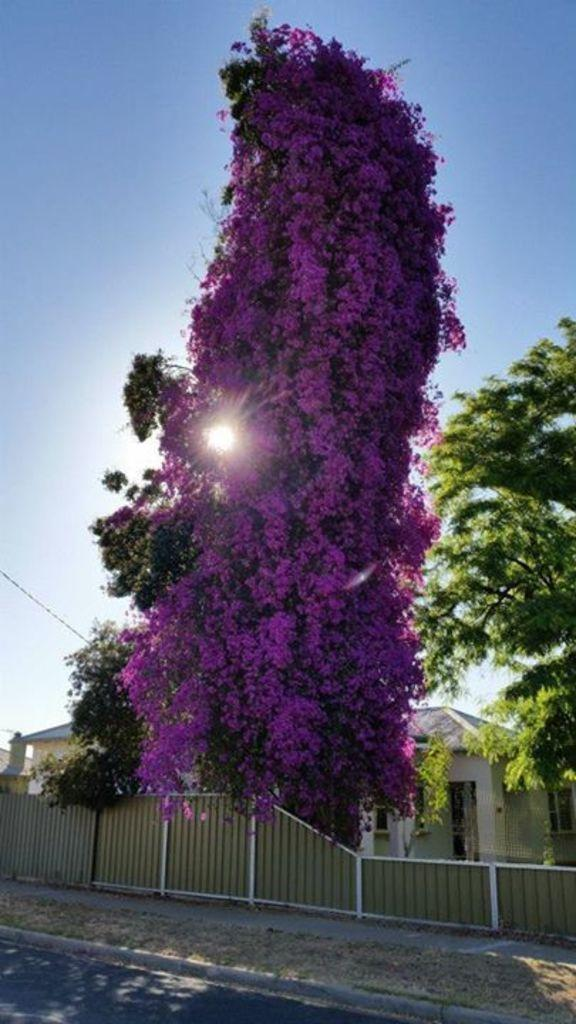What structures are located in the center of the image? There are sheds in the center of the image. What type of barrier can be seen in the image? There is a fence in the image. What can be seen in the background of the image? There are trees in the background of the image. What is the source of light in the image? Sunlight is visible in the image. What is at the bottom of the image? There is a road at the bottom of the image. What type of weather can be seen on the page in the image? There is no page present in the image, and therefore no weather can be observed. How many amounts of sunlight are visible in the image? There is only one source of sunlight visible in the image. 